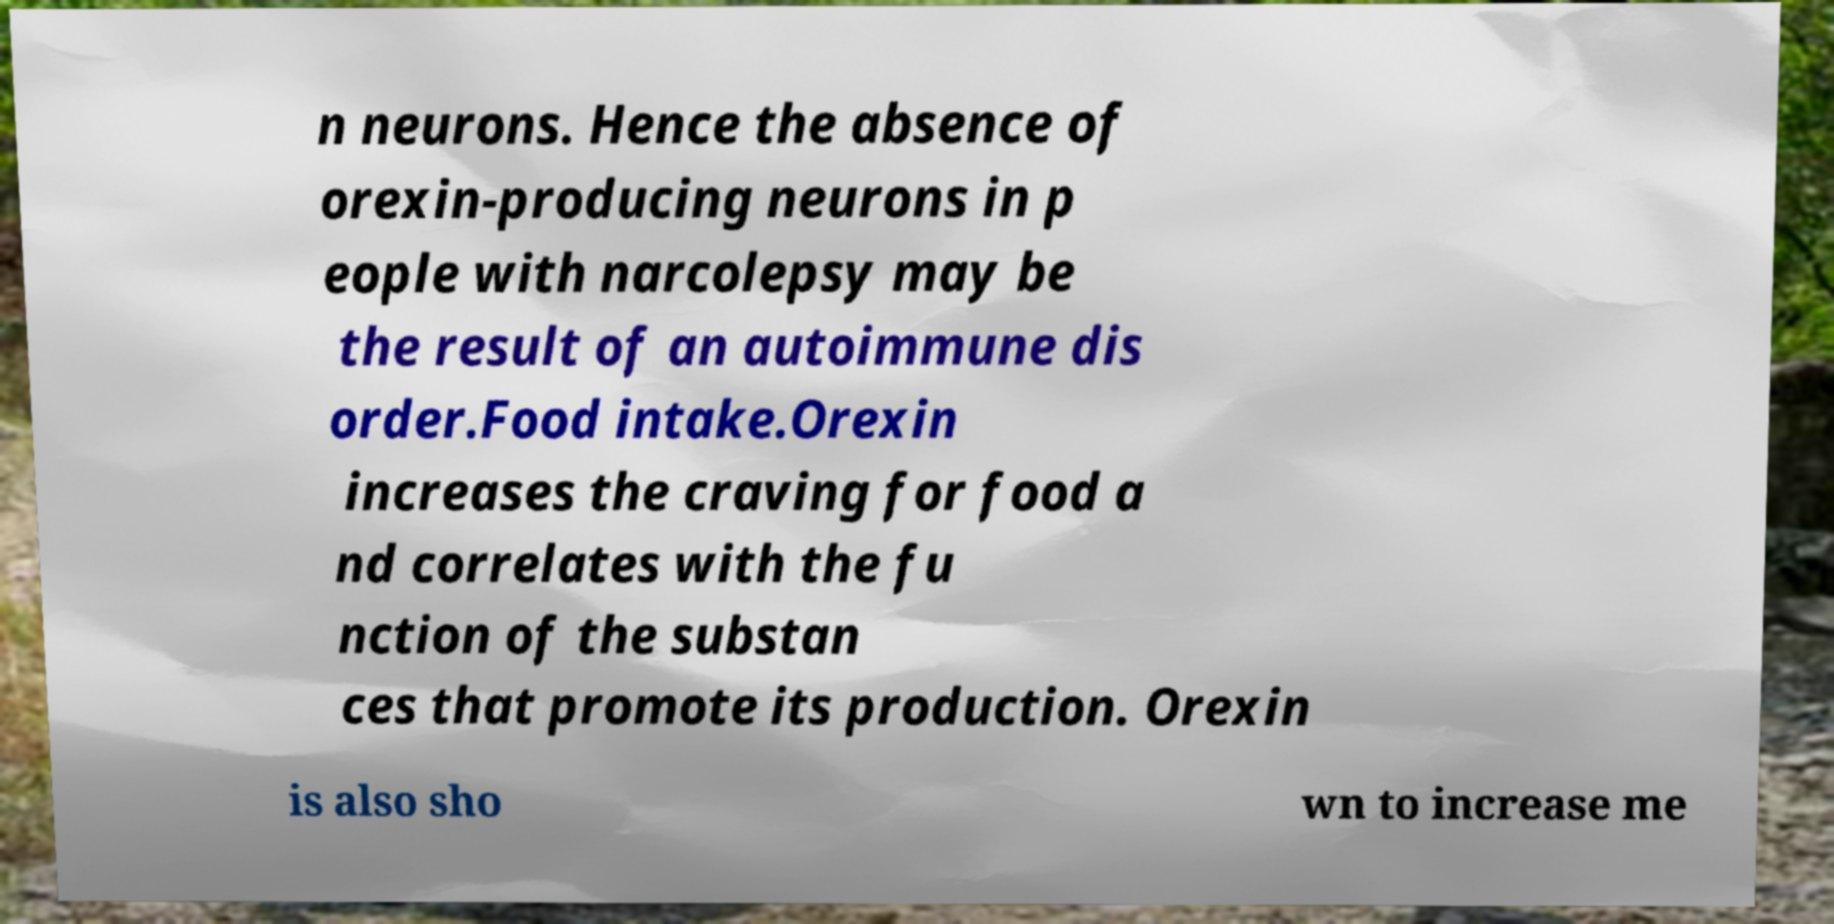Could you assist in decoding the text presented in this image and type it out clearly? n neurons. Hence the absence of orexin-producing neurons in p eople with narcolepsy may be the result of an autoimmune dis order.Food intake.Orexin increases the craving for food a nd correlates with the fu nction of the substan ces that promote its production. Orexin is also sho wn to increase me 